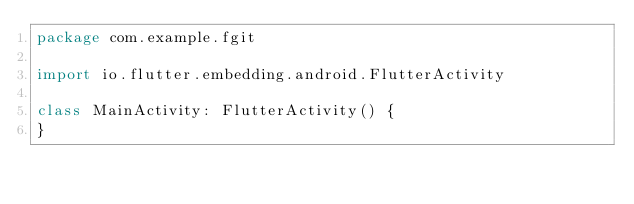Convert code to text. <code><loc_0><loc_0><loc_500><loc_500><_Kotlin_>package com.example.fgit

import io.flutter.embedding.android.FlutterActivity

class MainActivity: FlutterActivity() {
}
</code> 